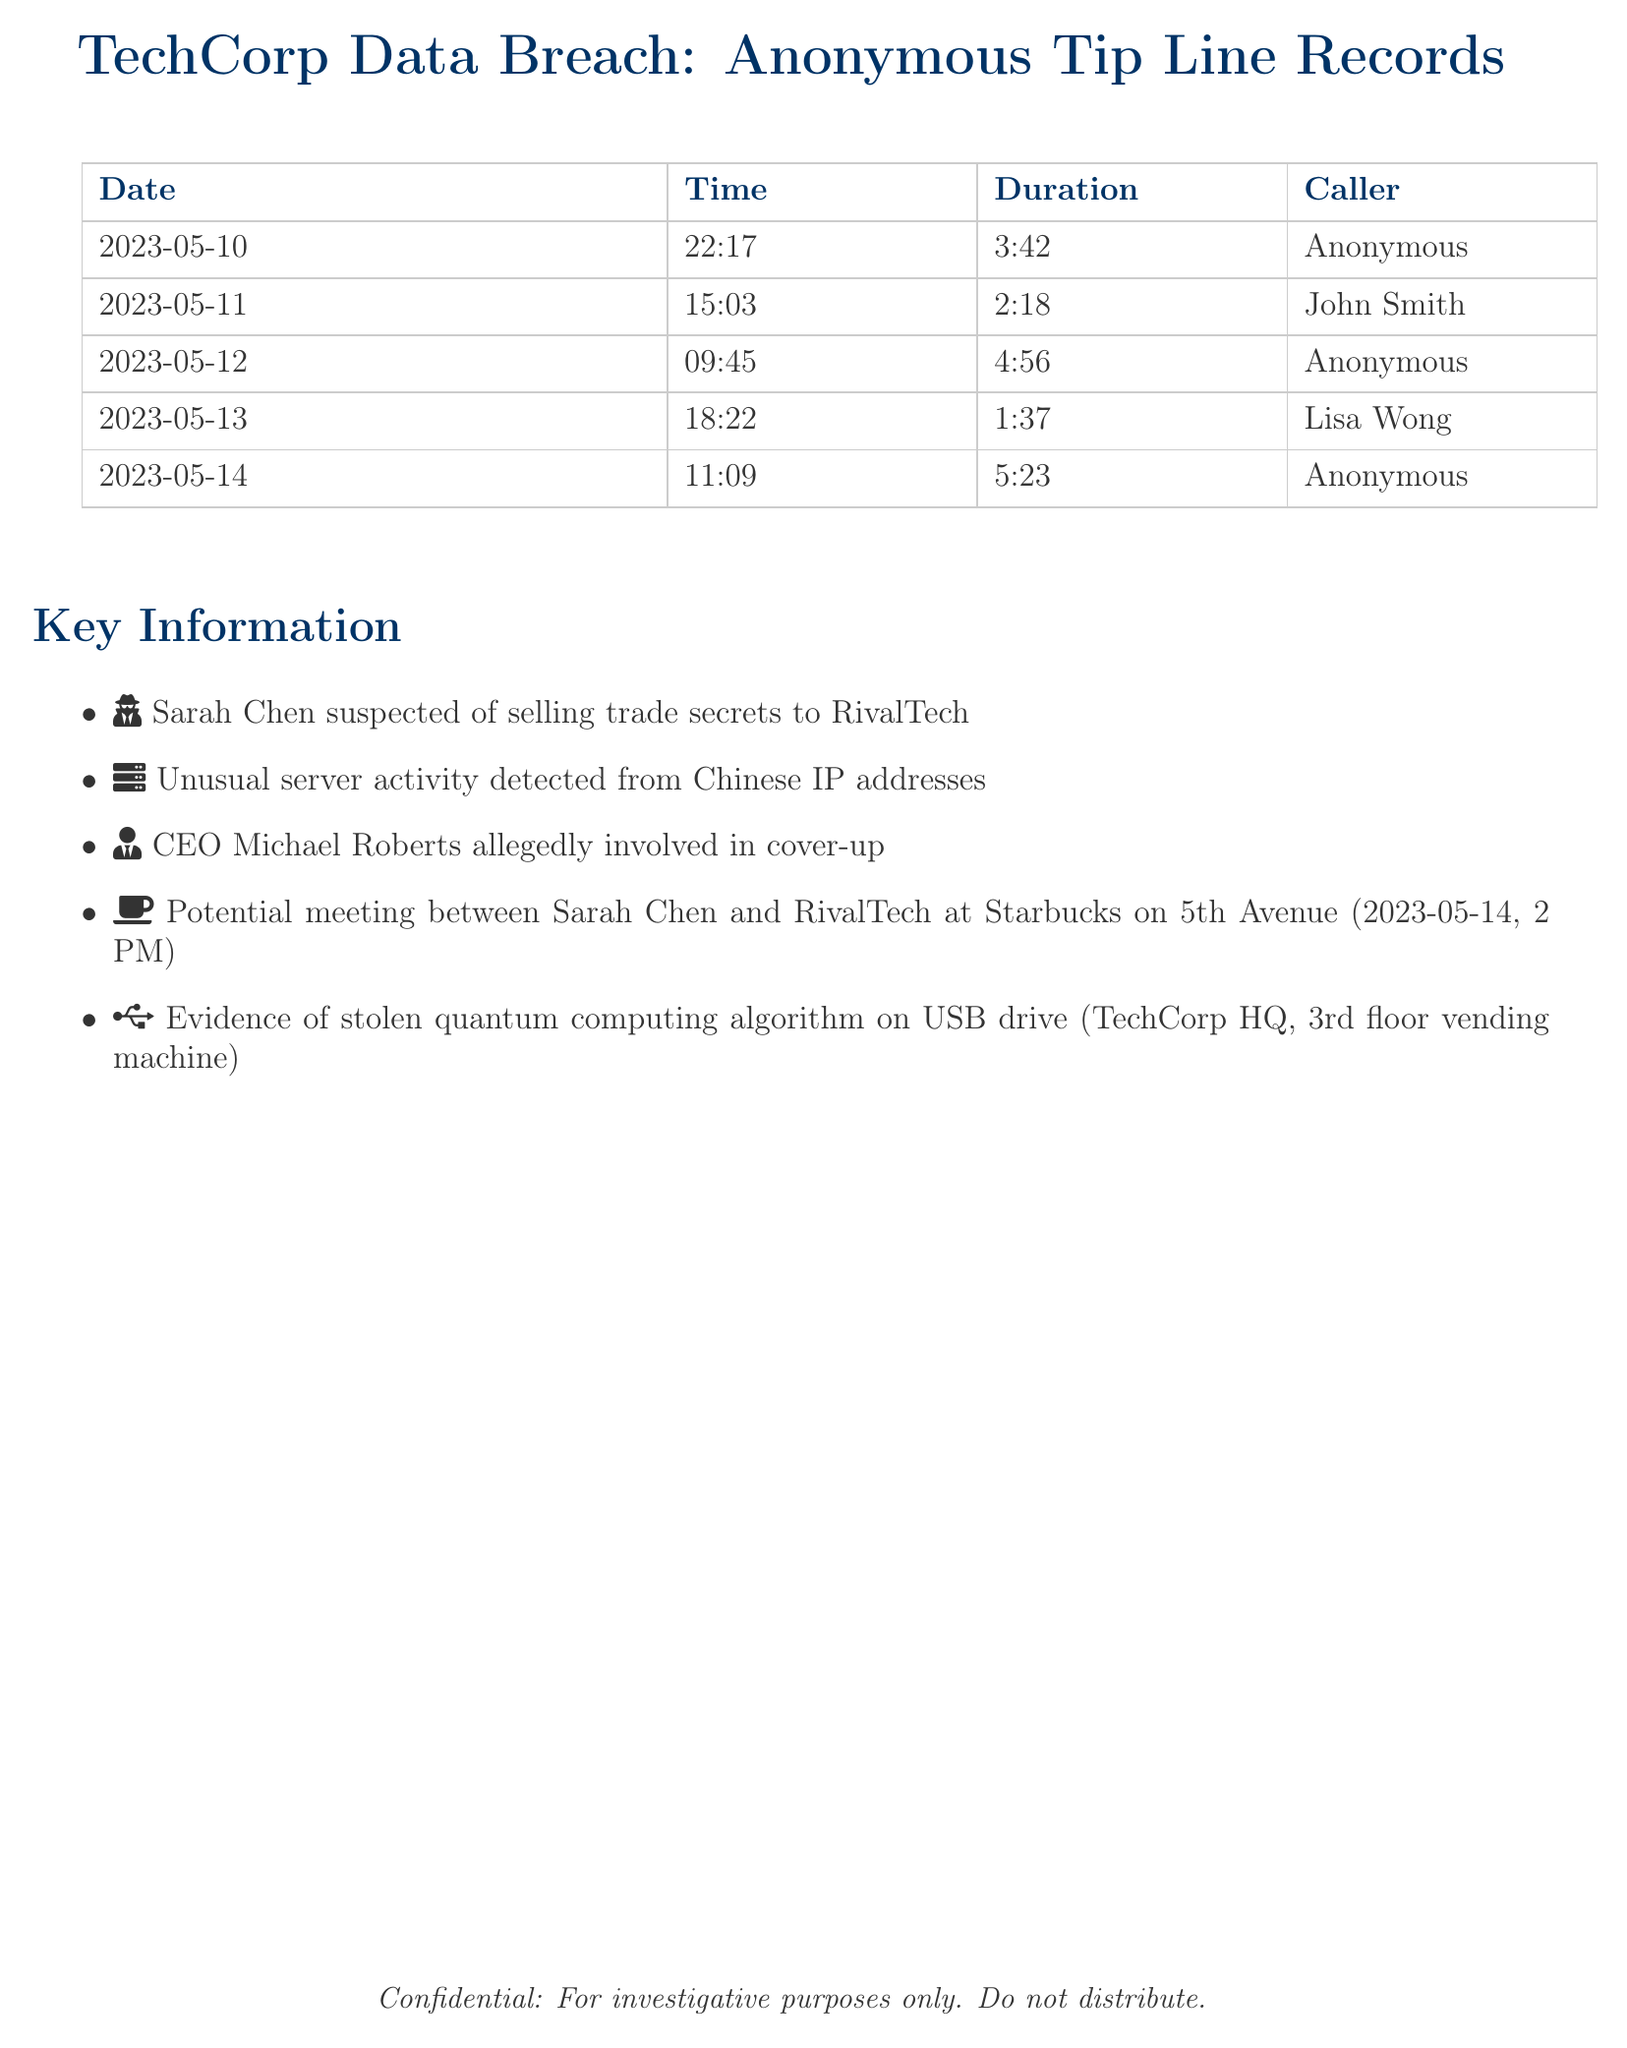what is the date of the first call? The first call in the records took place on May 10, 2023.
Answer: May 10, 2023 who made the call on May 11, 2023? The call on that date was made by John Smith.
Answer: John Smith what was the duration of the call made by Lisa Wong? Lisa Wong's call lasted for 1 minute and 37 seconds.
Answer: 1:37 how many calls were made by Anonymous? There are three calls recorded from Anonymous.
Answer: 3 what key person is suspected of selling trade secrets? Sarah Chen is suspected of the act mentioned.
Answer: Sarah Chen what unusual activity was detected related to the breach? The document mentions unusual server activity from Chinese IP addresses.
Answer: Chinese IP addresses what is the potential meeting location mentioned in the document? The potential meeting between Sarah Chen and RivalTech is planned at Starbucks on 5th Avenue.
Answer: Starbucks on 5th Avenue how long was the longest call recorded? The longest call duration recorded is 5 minutes and 23 seconds.
Answer: 5:23 who is allegedly involved in a cover-up? CEO Michael Roberts is allegedly involved in the cover-up.
Answer: Michael Roberts 